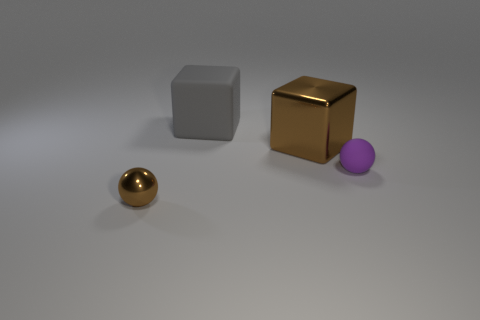Add 1 big shiny objects. How many objects exist? 5 Subtract all tiny purple rubber spheres. Subtract all big brown shiny objects. How many objects are left? 2 Add 3 rubber balls. How many rubber balls are left? 4 Add 2 brown metal things. How many brown metal things exist? 4 Subtract 0 red spheres. How many objects are left? 4 